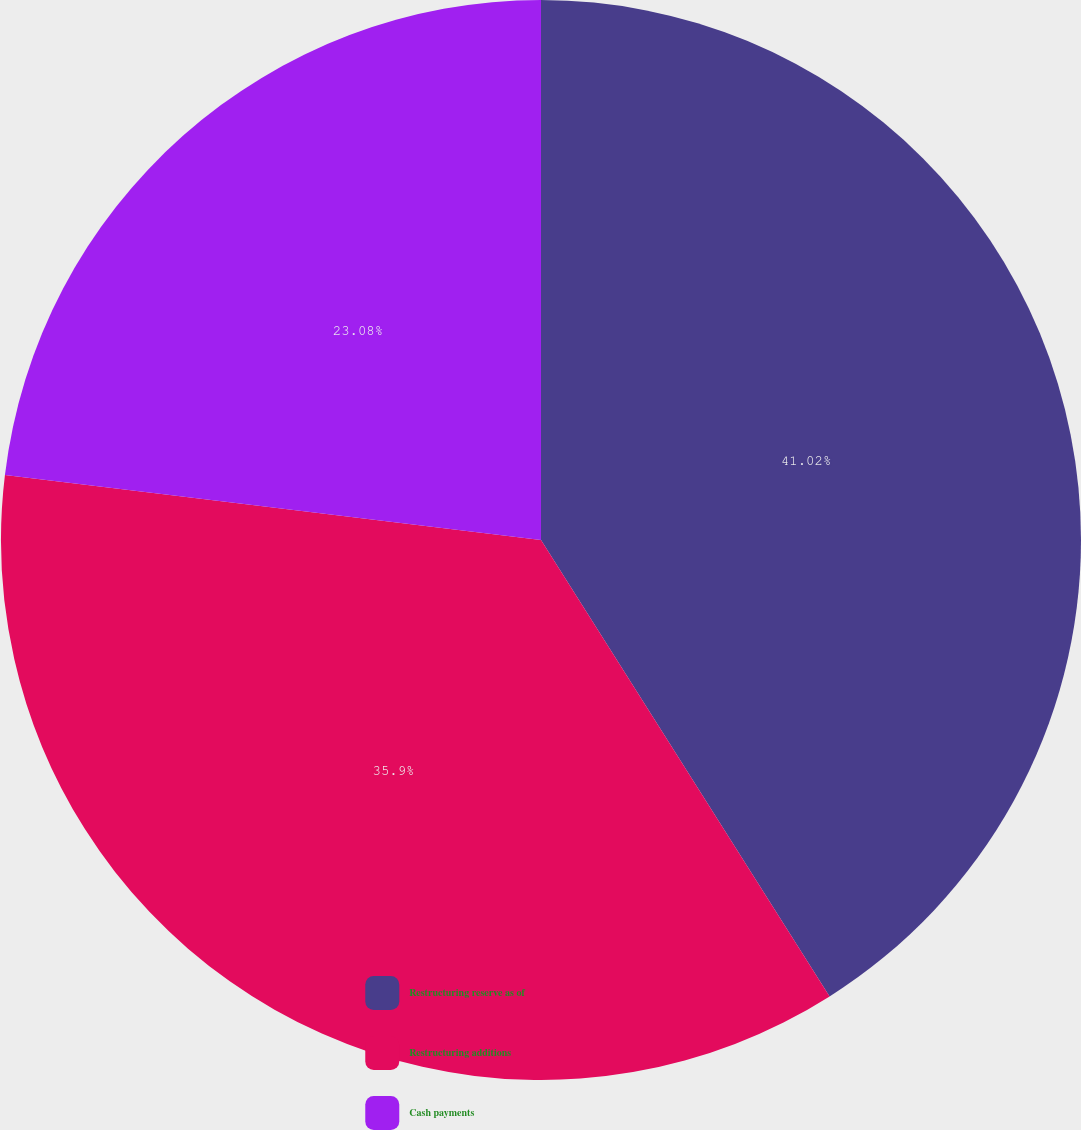<chart> <loc_0><loc_0><loc_500><loc_500><pie_chart><fcel>Restructuring reserve as of<fcel>Restructuring additions<fcel>Cash payments<nl><fcel>41.03%<fcel>35.9%<fcel>23.08%<nl></chart> 